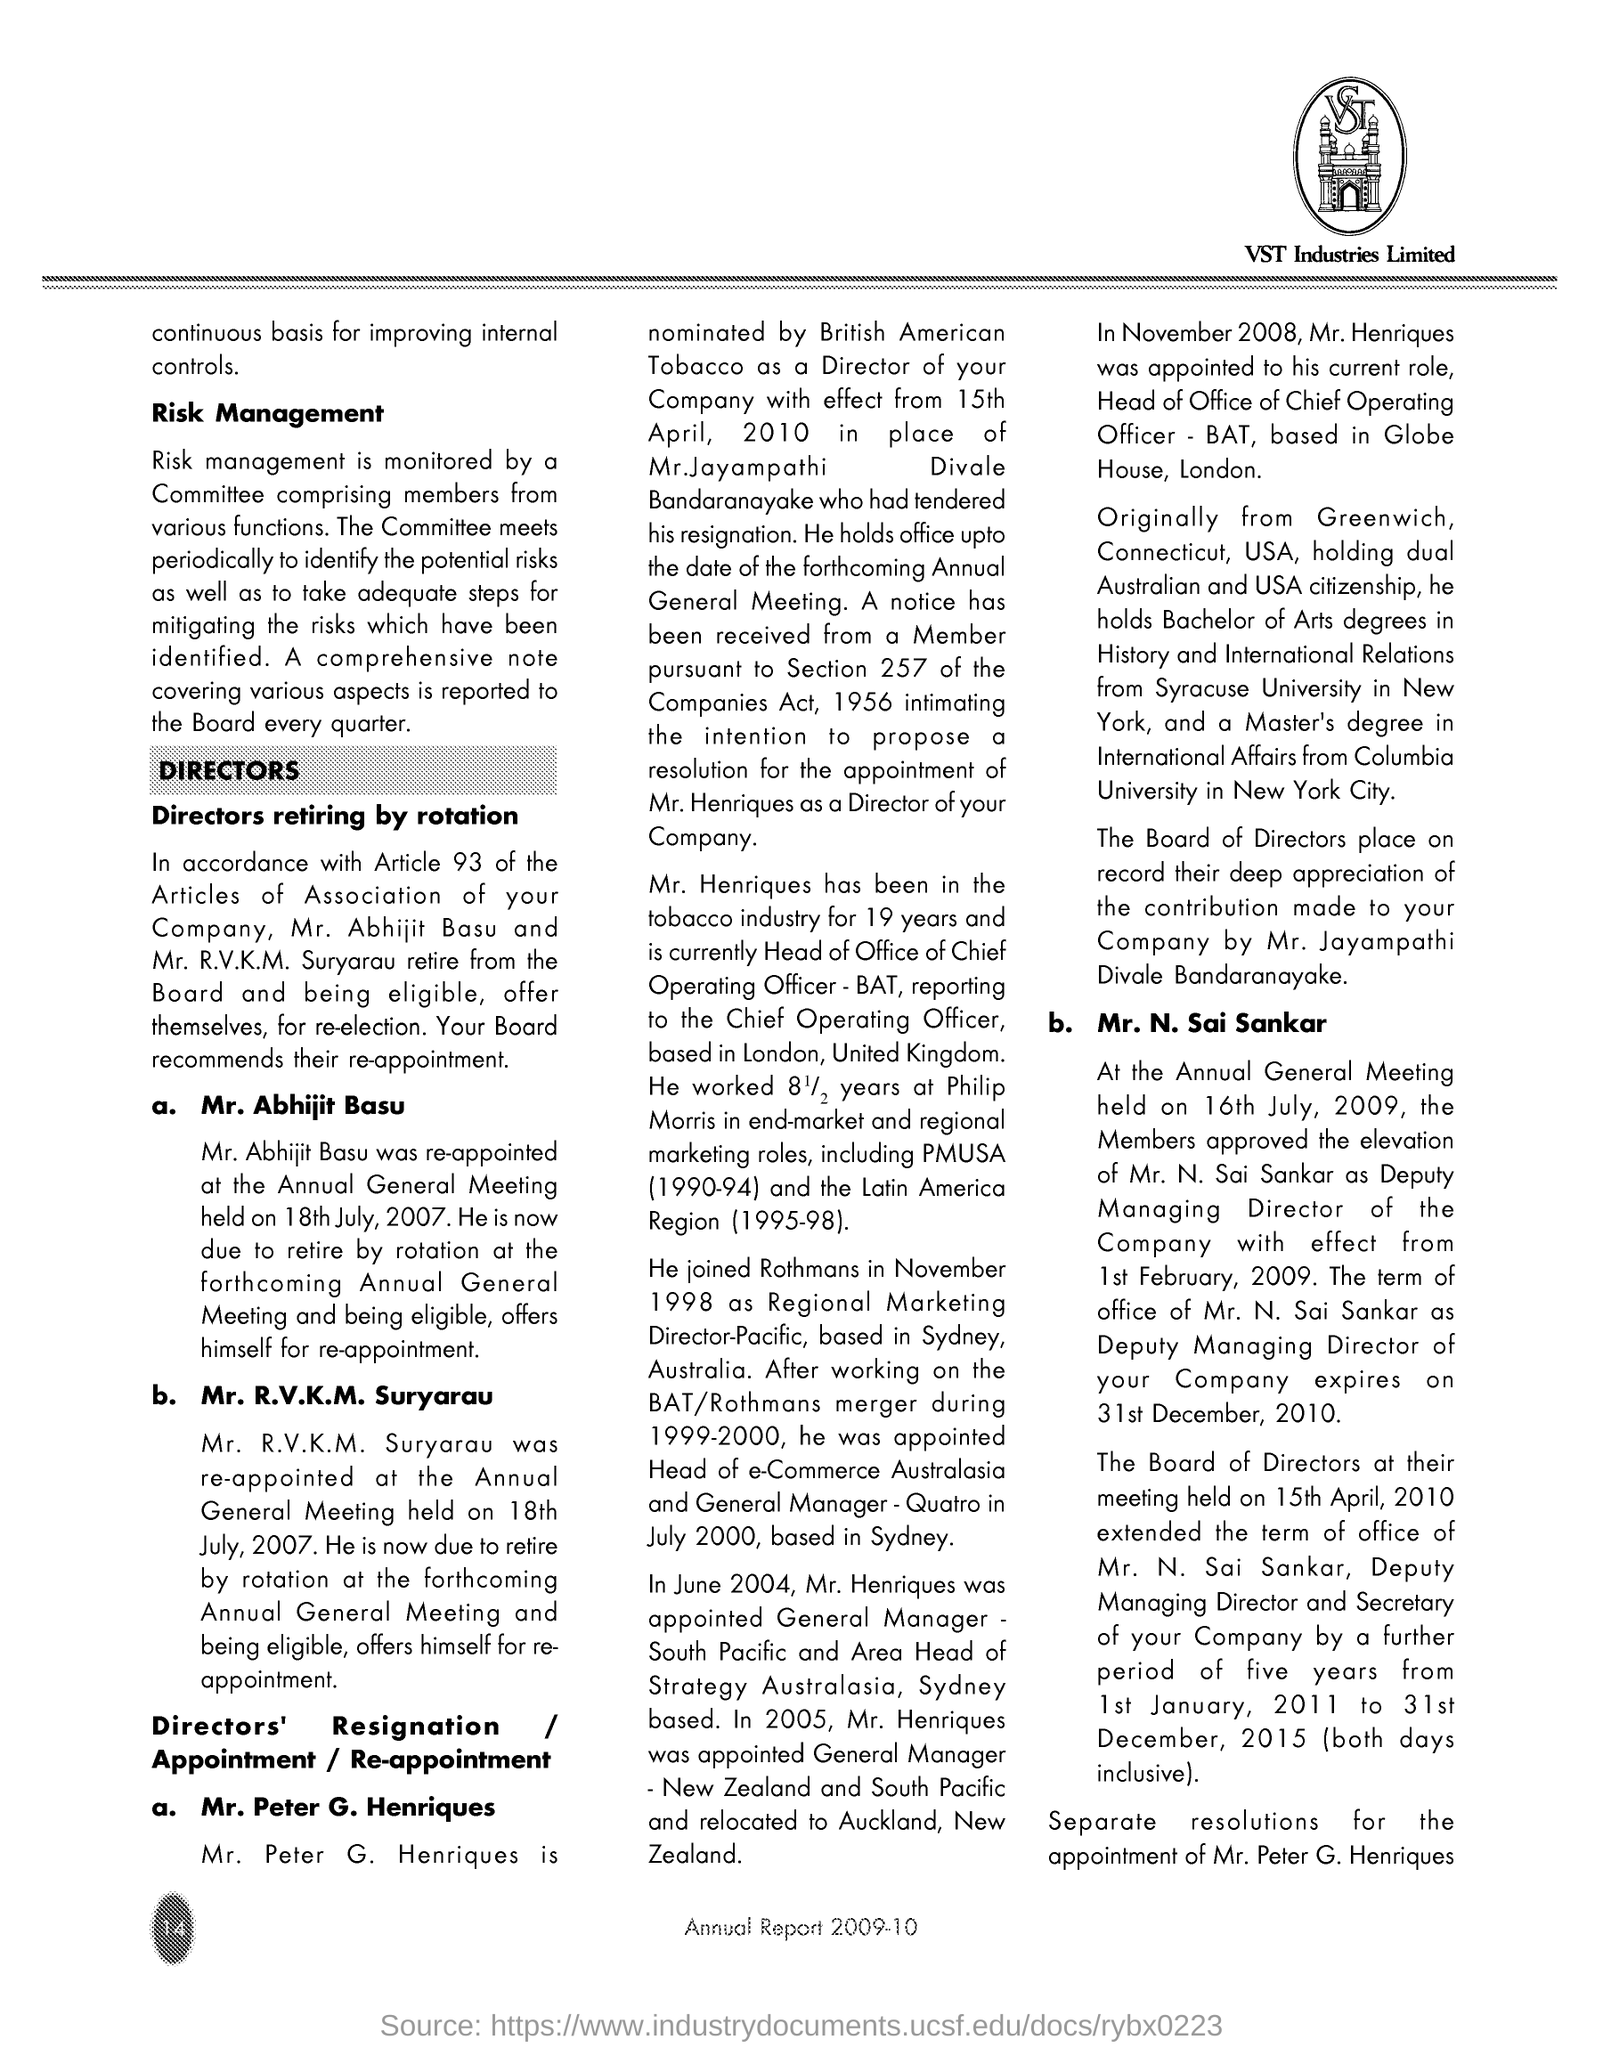Point out several critical features in this image. At the meeting held on [insert date], Mr. Abhijit Basu was re-appointed. The text located within the logo, positioned at the right top corner of the page, is labeled as VST. The logo of VST Industries Limited is displayed. The elevation of Mr. N. Sai Sankar as Deputy Managing Director of the company was approved by its members on 16th July, 2009. The document provides information about an "Annual Report" from a specific year, which is indicated at the bottom of the page as 2009-10. 